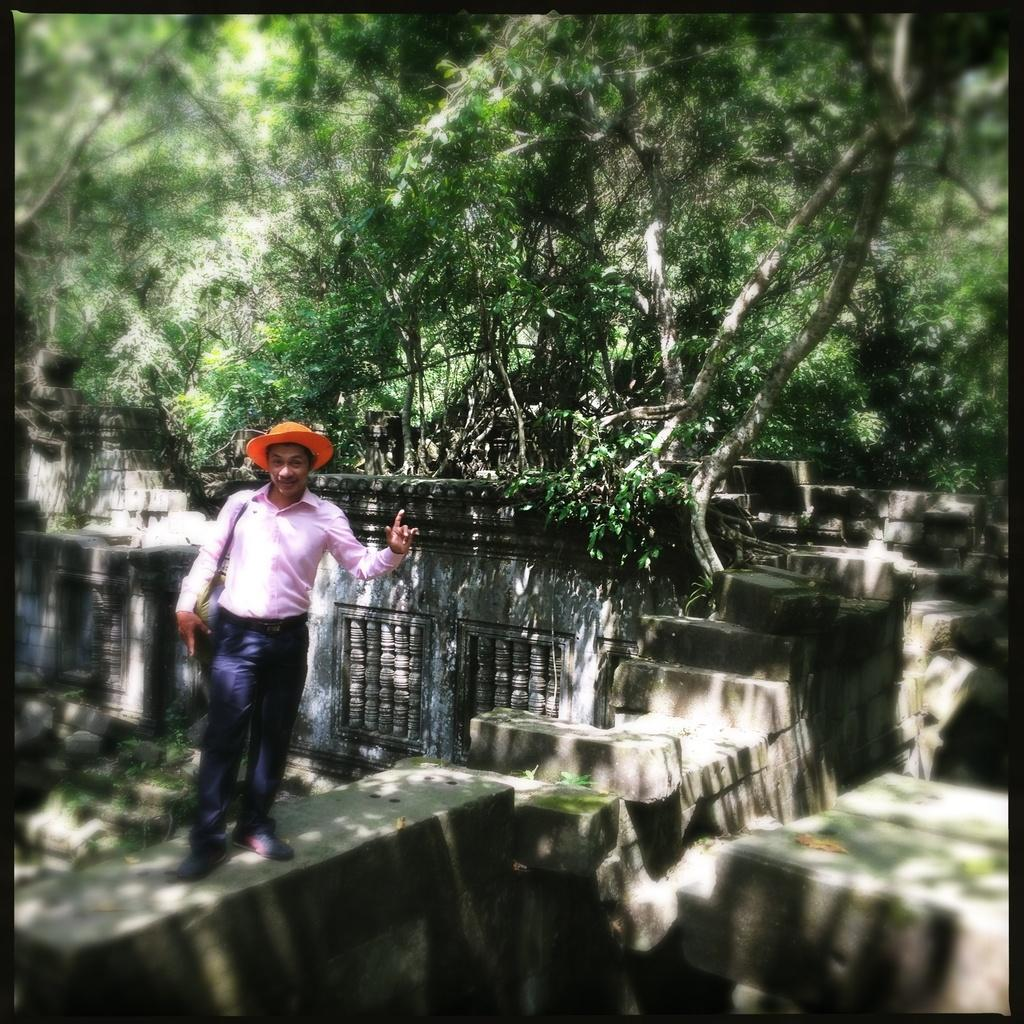What is the main subject in the image? There is a man standing in the image. What can be seen in the background of the image? There are rocks and trees in the background of the image. What color is the blood on the man's toes in the image? There is no blood or mention of toes in the image; it only features a man standing and rocks and trees in the background. 